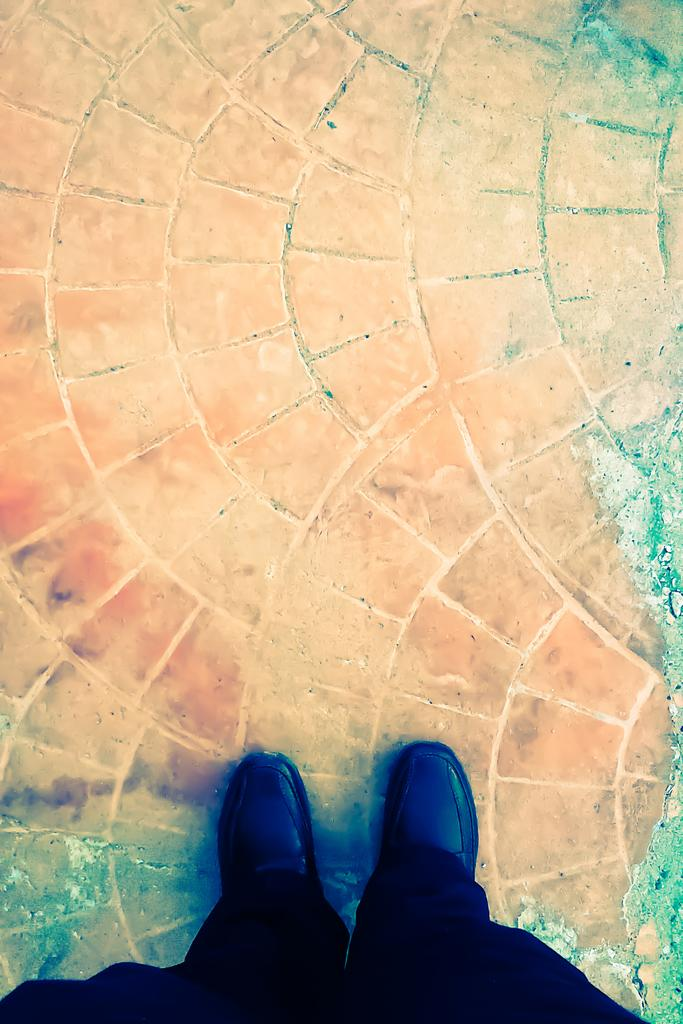What is the main subject of the image? There is a person standing in the image. What is the person standing on? The person is standing on land. What color are the pants the person is wearing? The person is wearing black pants. What type of footwear is the person wearing? The person is wearing black shoes. What type of club does the person belong to in the image? There is no indication in the image that the person belongs to any club. What smell can be detected in the image? There is no information about smells in the image. 